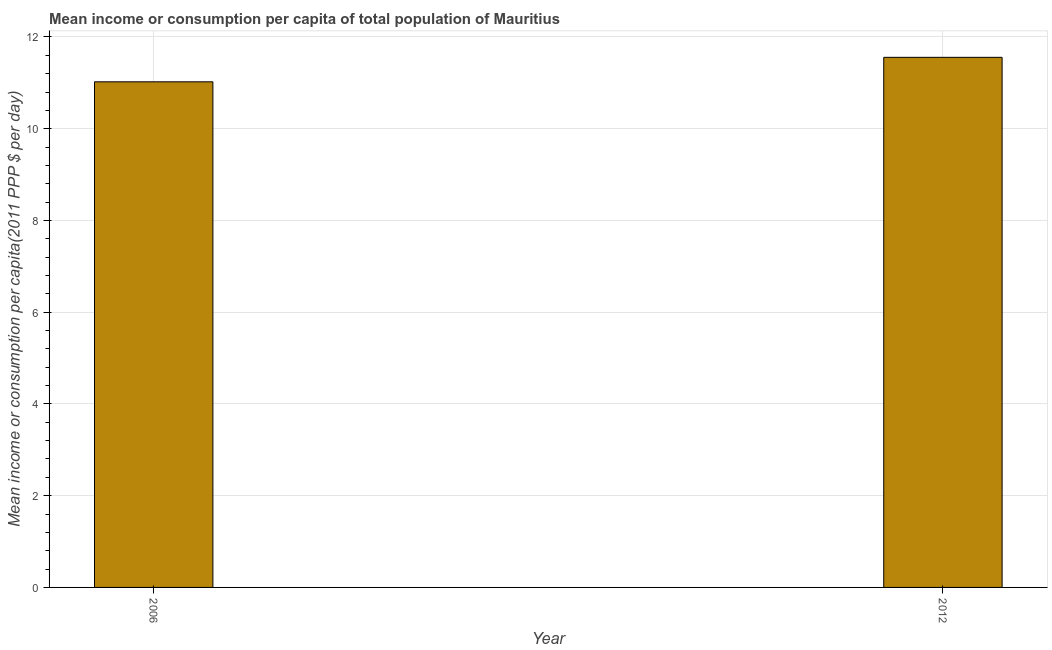Does the graph contain grids?
Give a very brief answer. Yes. What is the title of the graph?
Your answer should be very brief. Mean income or consumption per capita of total population of Mauritius. What is the label or title of the X-axis?
Keep it short and to the point. Year. What is the label or title of the Y-axis?
Give a very brief answer. Mean income or consumption per capita(2011 PPP $ per day). What is the mean income or consumption in 2006?
Your answer should be very brief. 11.02. Across all years, what is the maximum mean income or consumption?
Your response must be concise. 11.56. Across all years, what is the minimum mean income or consumption?
Your answer should be very brief. 11.02. In which year was the mean income or consumption minimum?
Your answer should be very brief. 2006. What is the sum of the mean income or consumption?
Give a very brief answer. 22.58. What is the difference between the mean income or consumption in 2006 and 2012?
Your answer should be compact. -0.53. What is the average mean income or consumption per year?
Offer a terse response. 11.29. What is the median mean income or consumption?
Give a very brief answer. 11.29. Do a majority of the years between 2006 and 2012 (inclusive) have mean income or consumption greater than 7.2 $?
Give a very brief answer. Yes. What is the ratio of the mean income or consumption in 2006 to that in 2012?
Give a very brief answer. 0.95. How many bars are there?
Ensure brevity in your answer.  2. How many years are there in the graph?
Provide a short and direct response. 2. What is the difference between two consecutive major ticks on the Y-axis?
Keep it short and to the point. 2. What is the Mean income or consumption per capita(2011 PPP $ per day) of 2006?
Give a very brief answer. 11.02. What is the Mean income or consumption per capita(2011 PPP $ per day) in 2012?
Ensure brevity in your answer.  11.56. What is the difference between the Mean income or consumption per capita(2011 PPP $ per day) in 2006 and 2012?
Ensure brevity in your answer.  -0.53. What is the ratio of the Mean income or consumption per capita(2011 PPP $ per day) in 2006 to that in 2012?
Your answer should be compact. 0.95. 